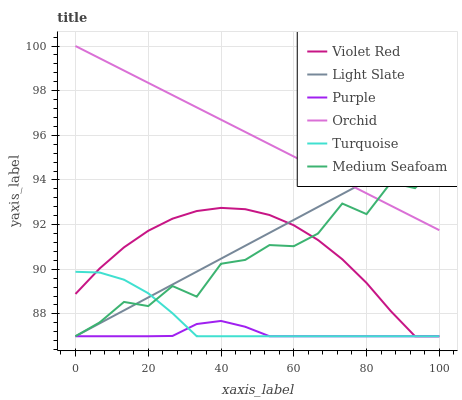Does Purple have the minimum area under the curve?
Answer yes or no. Yes. Does Orchid have the maximum area under the curve?
Answer yes or no. Yes. Does Light Slate have the minimum area under the curve?
Answer yes or no. No. Does Light Slate have the maximum area under the curve?
Answer yes or no. No. Is Orchid the smoothest?
Answer yes or no. Yes. Is Medium Seafoam the roughest?
Answer yes or no. Yes. Is Light Slate the smoothest?
Answer yes or no. No. Is Light Slate the roughest?
Answer yes or no. No. Does Violet Red have the lowest value?
Answer yes or no. Yes. Does Orchid have the lowest value?
Answer yes or no. No. Does Orchid have the highest value?
Answer yes or no. Yes. Does Light Slate have the highest value?
Answer yes or no. No. Is Purple less than Orchid?
Answer yes or no. Yes. Is Orchid greater than Turquoise?
Answer yes or no. Yes. Does Orchid intersect Medium Seafoam?
Answer yes or no. Yes. Is Orchid less than Medium Seafoam?
Answer yes or no. No. Is Orchid greater than Medium Seafoam?
Answer yes or no. No. Does Purple intersect Orchid?
Answer yes or no. No. 